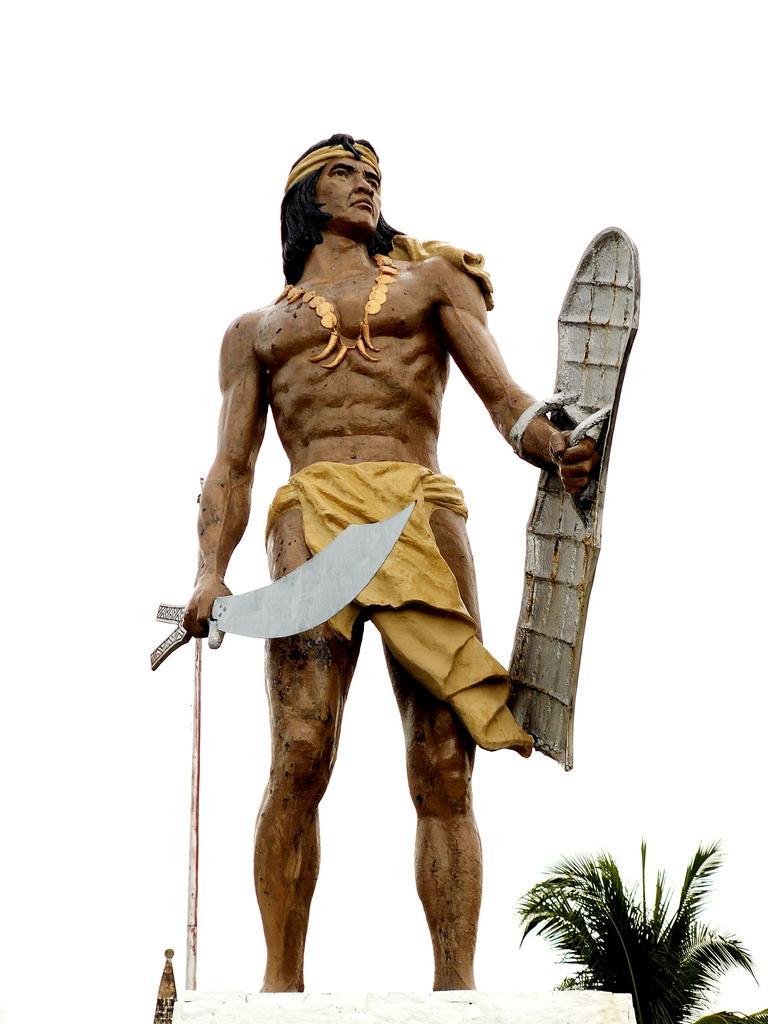Please provide a concise description of this image. In this picture I can see a statue of a person standing and holding a Chinese war sword and a war shield, there is a tree, and in the background there is sky. 